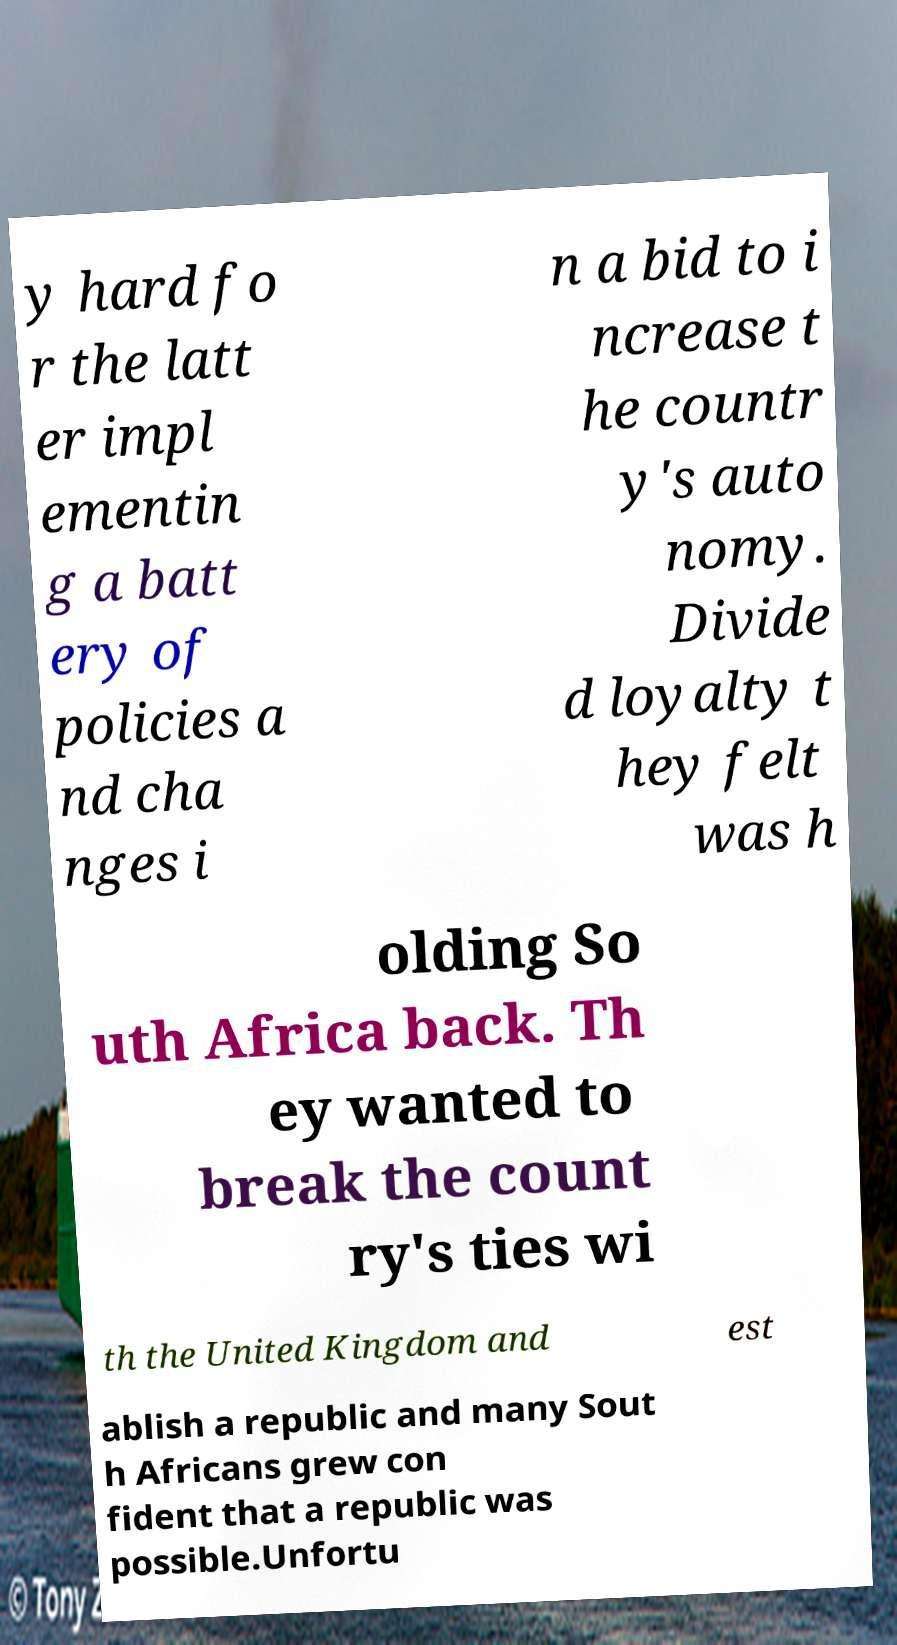Can you read and provide the text displayed in the image?This photo seems to have some interesting text. Can you extract and type it out for me? y hard fo r the latt er impl ementin g a batt ery of policies a nd cha nges i n a bid to i ncrease t he countr y's auto nomy. Divide d loyalty t hey felt was h olding So uth Africa back. Th ey wanted to break the count ry's ties wi th the United Kingdom and est ablish a republic and many Sout h Africans grew con fident that a republic was possible.Unfortu 